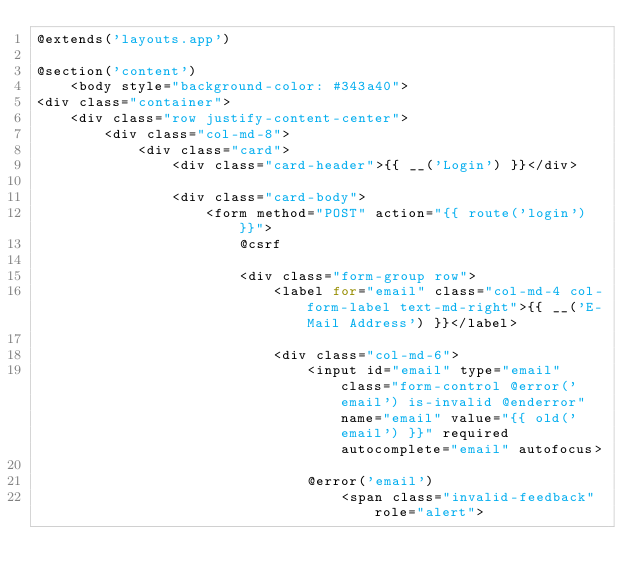<code> <loc_0><loc_0><loc_500><loc_500><_PHP_>@extends('layouts.app')

@section('content')
    <body style="background-color: #343a40">
<div class="container">
    <div class="row justify-content-center">
        <div class="col-md-8">
            <div class="card">
                <div class="card-header">{{ __('Login') }}</div>

                <div class="card-body">
                    <form method="POST" action="{{ route('login') }}">
                        @csrf

                        <div class="form-group row">
                            <label for="email" class="col-md-4 col-form-label text-md-right">{{ __('E-Mail Address') }}</label>

                            <div class="col-md-6">
                                <input id="email" type="email" class="form-control @error('email') is-invalid @enderror" name="email" value="{{ old('email') }}" required autocomplete="email" autofocus>

                                @error('email')
                                    <span class="invalid-feedback" role="alert"></code> 